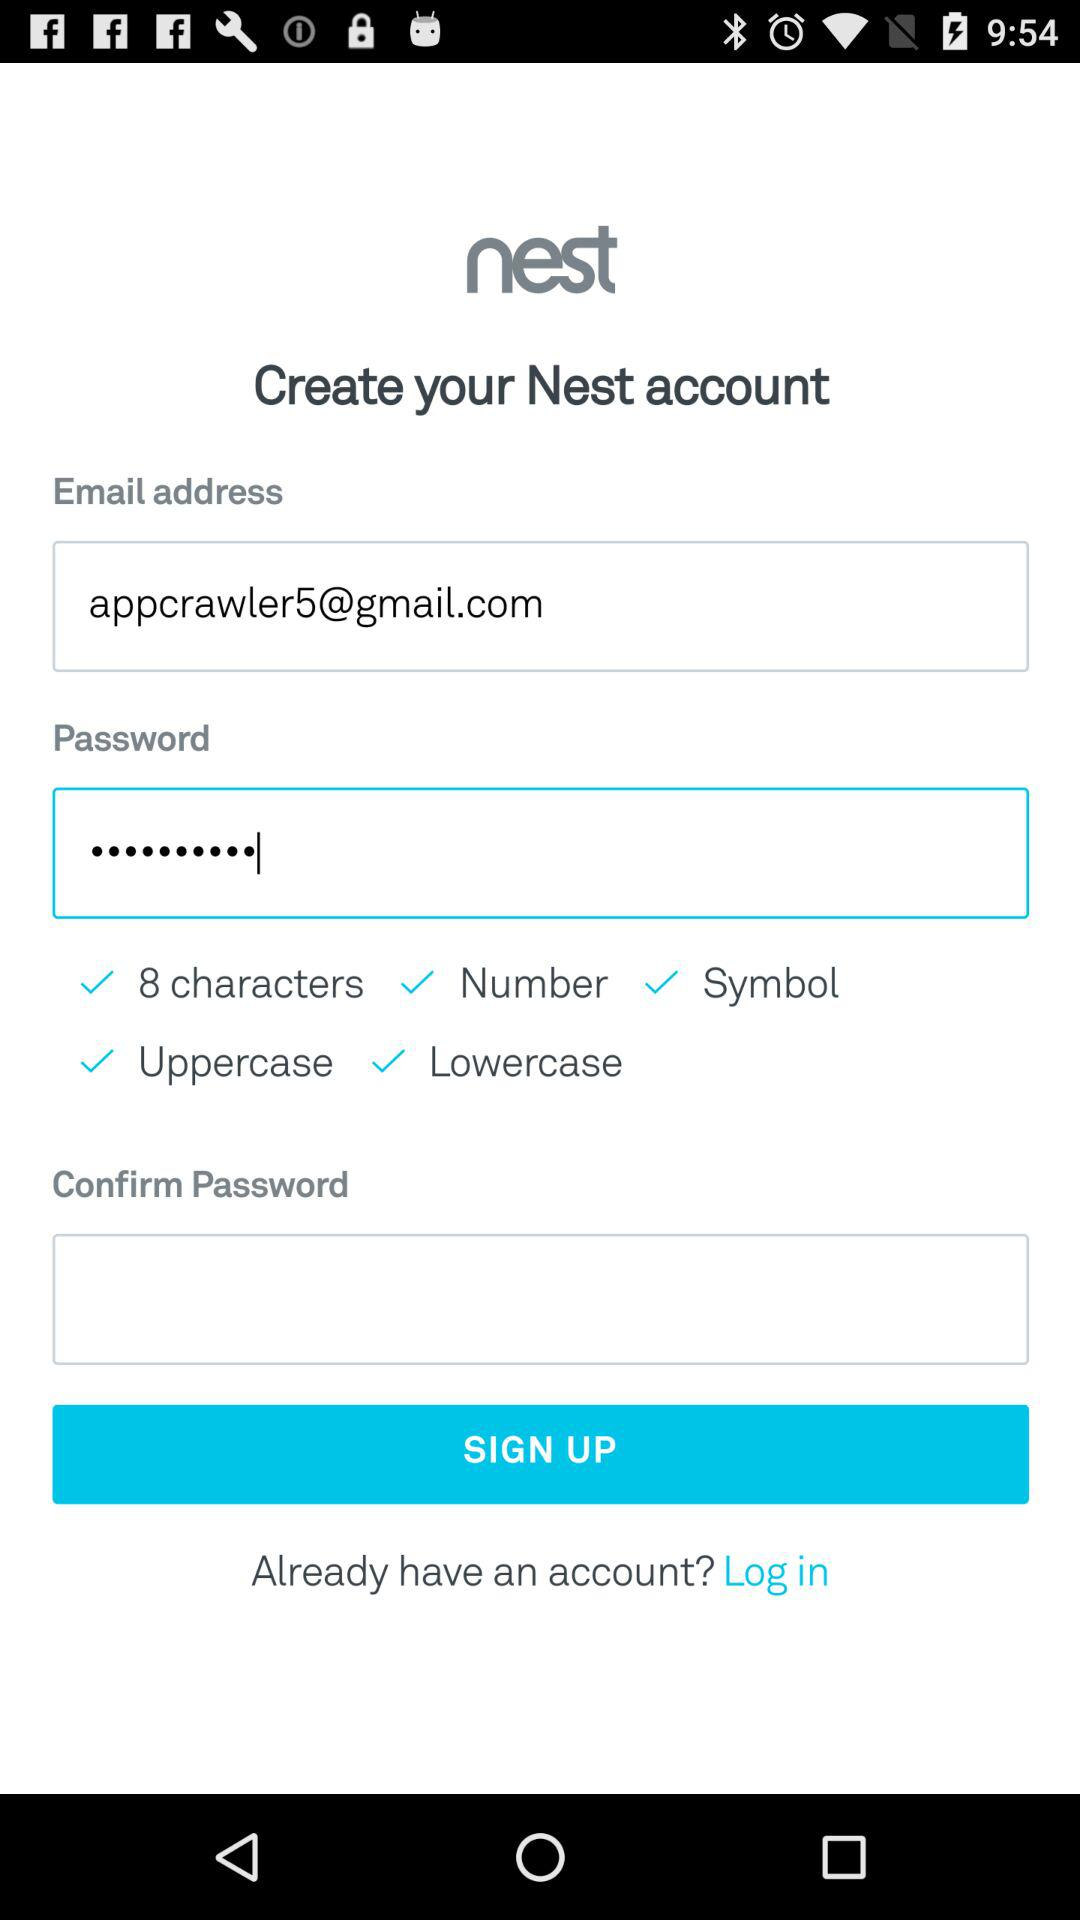What is the email address? The email address is appcrawler5@gmail.com. 